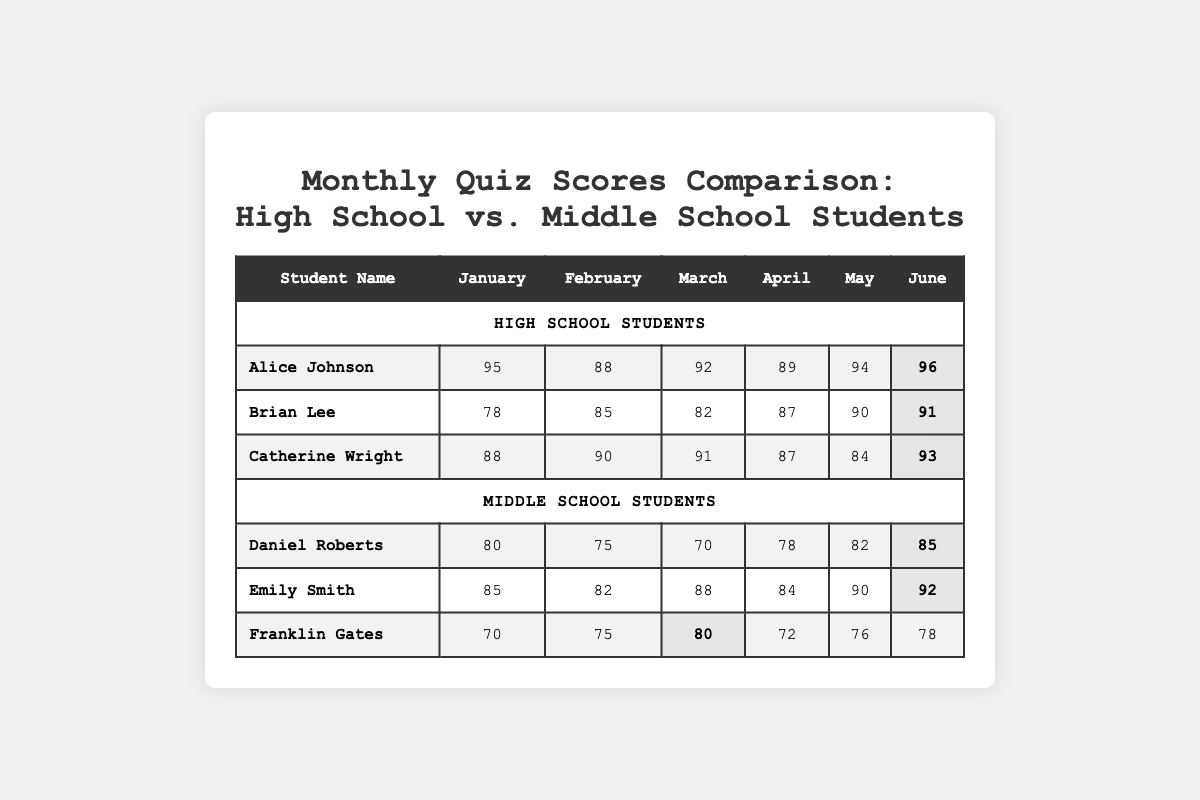What was Alice Johnson's highest score? Looking at Alice Johnson's row, the highest score she received across all months is listed under June, which is 96.
Answer: 96 What is the average score of Brian Lee for the first three months? To find the average, we sum his scores for January (78), February (85), and March (82): 78 + 85 + 82 = 245. Then, divide by 3 which gives us 245 / 3 = 81.67 (rounded to 82).
Answer: 82 Did any middle school student score above 90 in May? Looking through May scores for middle school students, Emily Smith scored 90, which is equal to 90 but not above. Daniel Roberts scored 82 and Franklin Gates scored 76, all of which are below 90.
Answer: No Who had the highest overall score in June among all students? In June, the scores are: Alice Johnson (96), Brian Lee (91), Catherine Wright (93), Daniel Roberts (85), Emily Smith (92), and Franklin Gates (78). The highest score is Alice Johnson's 96.
Answer: Alice Johnson What is the total score of Catherine Wright across all months? Adding up Catherine Wright's scores gives us: 88 + 90 + 91 + 87 + 84 + 93 = 523.
Answer: 523 Between Emily Smith and Brian Lee, who had a higher average score over the six months? Emily Smith's total scores: 85 + 82 + 88 + 84 + 90 + 92 = 521; average = 521 / 6 = 86.83. Brian Lee's total is 78 + 85 + 82 + 87 + 90 + 91 = 513; average = 513 / 6 = 85.5. Comparing averages, Emily Smith has the higher average.
Answer: Emily Smith What is the range of scores for Franklin Gates across all months? The minimum score Franklin achieved is 70 (January) and the maximum is 80 (March). To find the range, calculate: 80 - 70 = 10.
Answer: 10 Which student had the most consistent performance based on their scores across the months? Evaluating the standard deviation of scores would help determine consistency, but qualitatively Catherine Wright has scores between 84 and 93, showing less fluctuation compared to others around larger gaps.
Answer: Catherine Wright Which month had the highest average score for high school students? The monthly averages for high school are: January (95 + 78 + 88) / 3 = 87; February (88 + 85 + 90) / 3 = 87.67; March (92 + 82 + 91) / 3 = 88.33; April (89 + 87 + 87) / 3 = 87.67; May (94 + 90 + 84) / 3 = 89.33; June (96 + 91 + 93) / 3 = 93.33. June has the highest average of 93.33.
Answer: June How many high school students scored above 90 in March? In March, the scores are: Alice Johnson (92), Brian Lee (82), and Catherine Wright (91). Alice Johnson and Catherine Wright are above 90, hence there are 2 students.
Answer: 2 